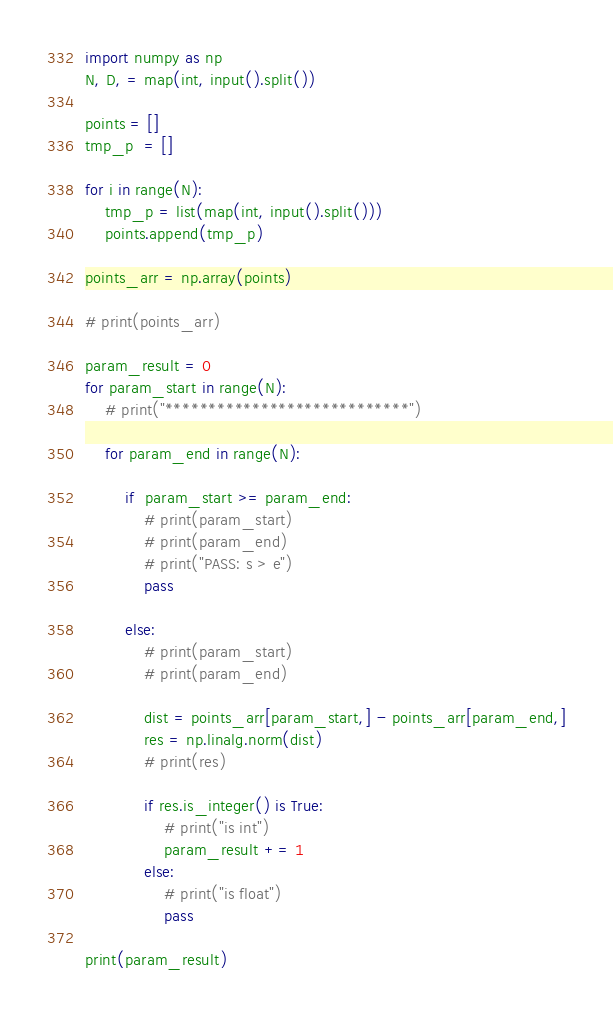Convert code to text. <code><loc_0><loc_0><loc_500><loc_500><_Python_>import numpy as np
N, D, = map(int, input().split())

points = []
tmp_p  = []

for i in range(N):
    tmp_p = list(map(int, input().split()))
    points.append(tmp_p)

points_arr = np.array(points)

# print(points_arr)

param_result = 0
for param_start in range(N):
    # print("****************************")

    for param_end in range(N):

        if  param_start >= param_end:
            # print(param_start)
            # print(param_end)
            # print("PASS: s > e")
            pass

        else:
            # print(param_start)
            # print(param_end)

            dist = points_arr[param_start,] - points_arr[param_end,]
            res = np.linalg.norm(dist)
            # print(res)

            if res.is_integer() is True:
                # print("is int")
                param_result += 1
            else:
                # print("is float")
                pass

print(param_result)</code> 